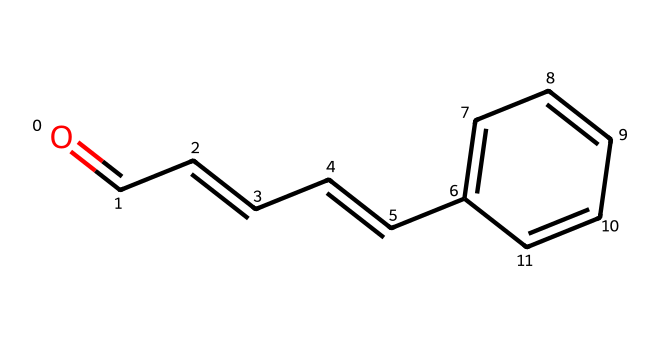What is the name of this chemical? The SMILES representation indicates the structure includes a carbonyl group (C=O) at the end of a carbon chain, which is characteristic of aldehydes, combined with the presence of a phenyl ring. This leads us to conclude that the compound is cinnamaldehyde, commonly found in cinnamon.
Answer: cinnamaldehyde How many carbon atoms are there in cinnamaldehyde? By analyzing the SMILES representation, the longest carbon chain with the attached phenyl ring shows a total of eight carbon atoms (C). Count each carbon atom present in the chain and the ring structure.
Answer: eight What is the functional group present in cinnamaldehyde? In the chemical structure, the C=O bond at the terminal position signifies the presence of an aldehyde functional group, which is identified by the carbonyl carbon being bonded to a hydrogen atom.
Answer: aldehyde How many double bonds are present in cinnamaldehyde? The SMILES notation reveals the existence of multiple double bonds. By examining the C=C bonds throughout the structure, we can count three double bonds in total, including the carbonyl group.
Answer: three What type of chemical is cinnamaldehyde classified as? Given the carbon chain structure and the presence of a carbonyl functional group, cinnamaldehyde is specifically categorised as an aldehyde. This classification is derived from the structural features characteristic of aldehydes.
Answer: aldehyde What is the total number of hydrogen atoms in cinnamaldehyde? To determine the number of hydrogen atoms, we can count the hydrogen atoms attached to each carbon: considering the double bonds and functional groups. This results in a count of eight hydrogen atoms present in the structure.
Answer: eight 